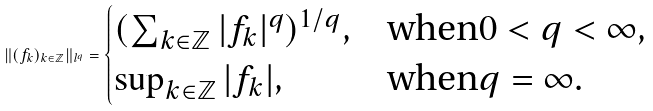<formula> <loc_0><loc_0><loc_500><loc_500>\| ( f _ { k } ) _ { k \in \mathbb { Z } } \| _ { l ^ { q } } = \begin{cases} ( \sum _ { k \in \mathbb { Z } } | f _ { k } | ^ { q } ) ^ { 1 / q } , & \text {when} 0 < q < \infty , \\ \sup _ { k \in \mathbb { Z } } | f _ { k } | , & \text {when} q = \infty . \end{cases}</formula> 